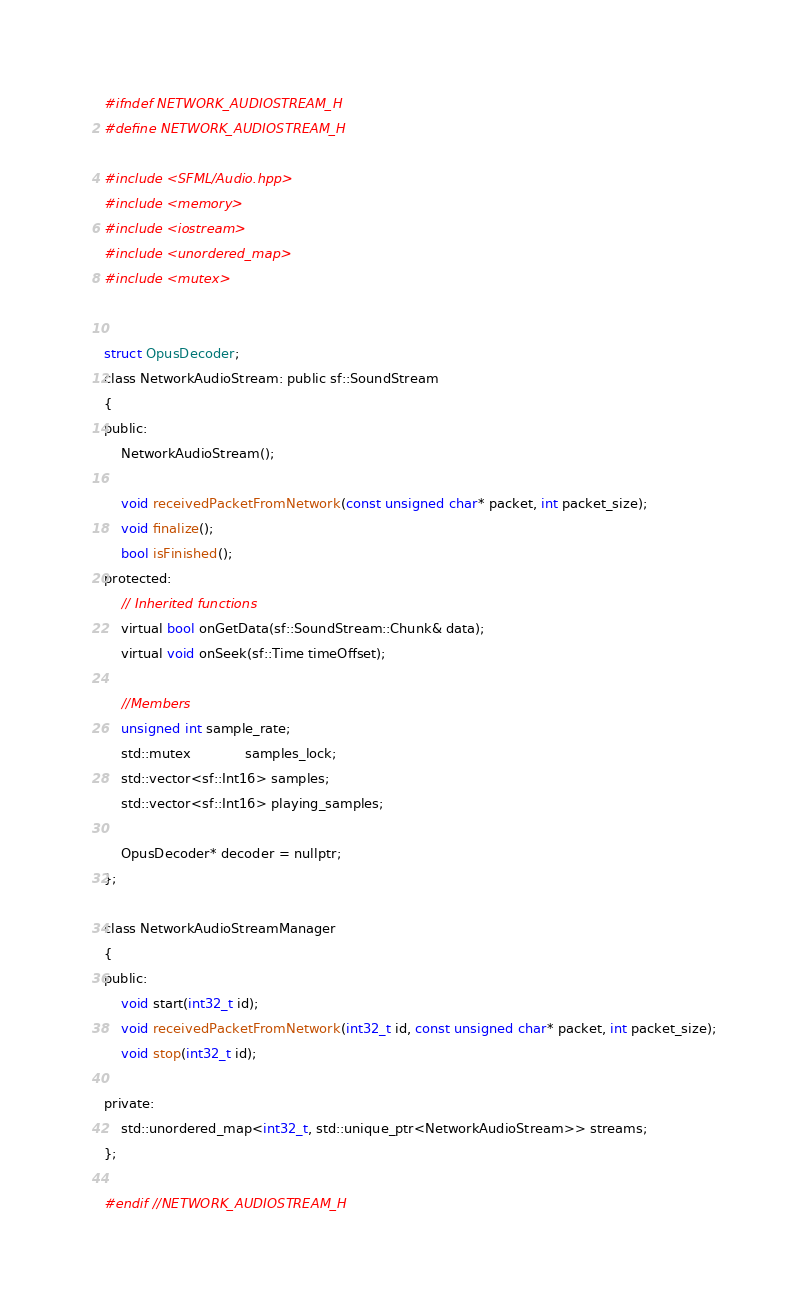<code> <loc_0><loc_0><loc_500><loc_500><_C_>#ifndef NETWORK_AUDIOSTREAM_H
#define NETWORK_AUDIOSTREAM_H

#include <SFML/Audio.hpp>
#include <memory>
#include <iostream>
#include <unordered_map>
#include <mutex>


struct OpusDecoder;
class NetworkAudioStream: public sf::SoundStream
{
public:
    NetworkAudioStream();

    void receivedPacketFromNetwork(const unsigned char* packet, int packet_size);
    void finalize();
    bool isFinished();
protected:
    // Inherited functions
    virtual bool onGetData(sf::SoundStream::Chunk& data);
    virtual void onSeek(sf::Time timeOffset);

    //Members
    unsigned int sample_rate;
    std::mutex             samples_lock;
    std::vector<sf::Int16> samples;
    std::vector<sf::Int16> playing_samples;

    OpusDecoder* decoder = nullptr;
};

class NetworkAudioStreamManager
{
public:
    void start(int32_t id);
    void receivedPacketFromNetwork(int32_t id, const unsigned char* packet, int packet_size);
    void stop(int32_t id);

private:
    std::unordered_map<int32_t, std::unique_ptr<NetworkAudioStream>> streams;
};

#endif //NETWORK_AUDIOSTREAM_H
</code> 